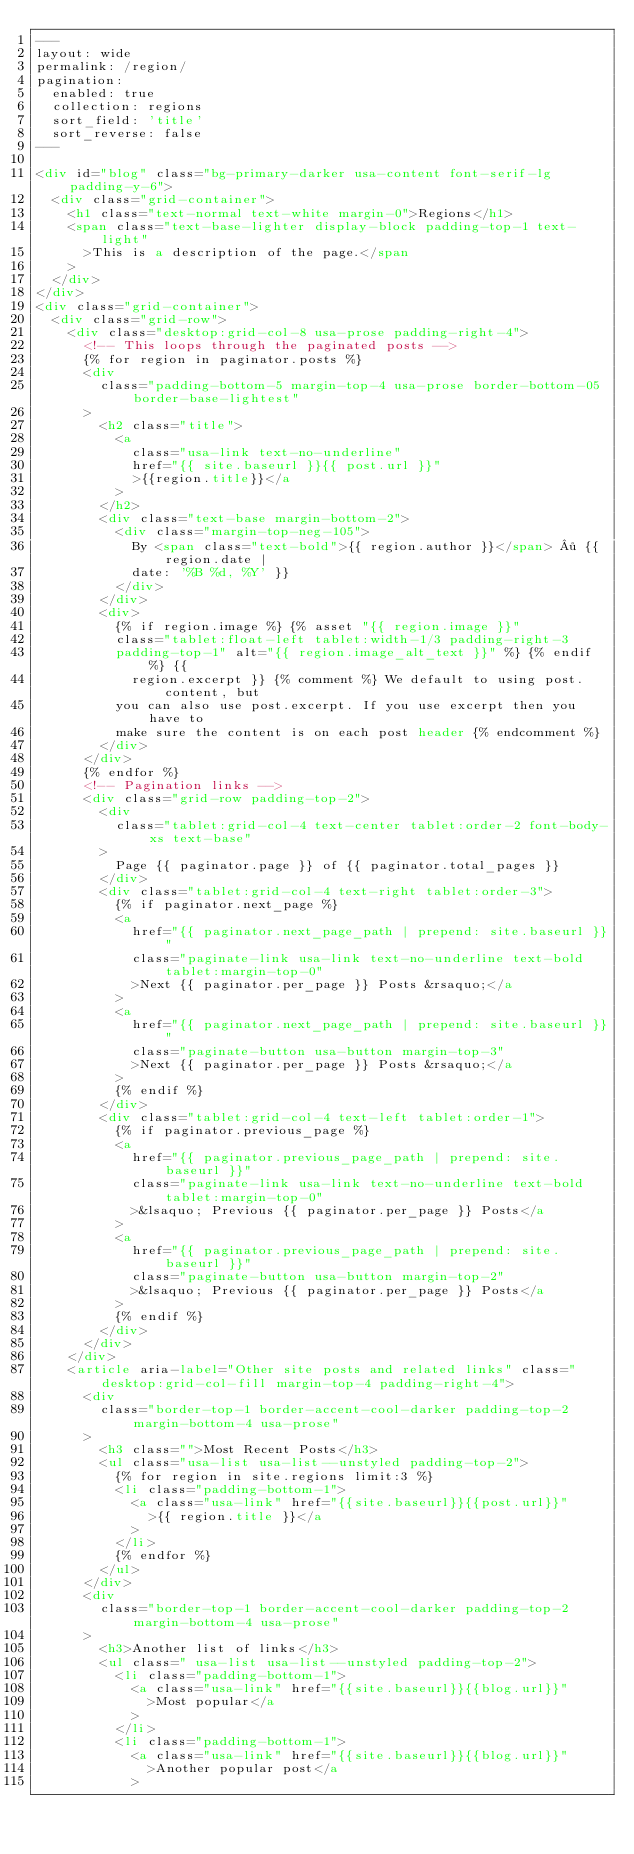Convert code to text. <code><loc_0><loc_0><loc_500><loc_500><_HTML_>---
layout: wide
permalink: /region/
pagination:
  enabled: true
  collection: regions
  sort_field: 'title'
  sort_reverse: false
---

<div id="blog" class="bg-primary-darker usa-content font-serif-lg padding-y-6">
  <div class="grid-container">
    <h1 class="text-normal text-white margin-0">Regions</h1>
    <span class="text-base-lighter display-block padding-top-1 text-light"
      >This is a description of the page.</span
    >
  </div>
</div>
<div class="grid-container">
  <div class="grid-row">
    <div class="desktop:grid-col-8 usa-prose padding-right-4">
      <!-- This loops through the paginated posts -->
      {% for region in paginator.posts %}
      <div
        class="padding-bottom-5 margin-top-4 usa-prose border-bottom-05 border-base-lightest"
      >
        <h2 class="title">
          <a
            class="usa-link text-no-underline"
            href="{{ site.baseurl }}{{ post.url }}"
            >{{region.title}}</a
          >
        </h2>
        <div class="text-base margin-bottom-2">
          <div class="margin-top-neg-105">
            By <span class="text-bold">{{ region.author }}</span> · {{ region.date |
            date: '%B %d, %Y' }}
          </div>
        </div>
        <div>
          {% if region.image %} {% asset "{{ region.image }}"
          class="tablet:float-left tablet:width-1/3 padding-right-3
          padding-top-1" alt="{{ region.image_alt_text }}" %} {% endif %} {{
            region.excerpt }} {% comment %} We default to using post.content, but
          you can also use post.excerpt. If you use excerpt then you have to
          make sure the content is on each post header {% endcomment %}
        </div>
      </div>
      {% endfor %}
      <!-- Pagination links -->
      <div class="grid-row padding-top-2">
        <div
          class="tablet:grid-col-4 text-center tablet:order-2 font-body-xs text-base"
        >
          Page {{ paginator.page }} of {{ paginator.total_pages }}
        </div>
        <div class="tablet:grid-col-4 text-right tablet:order-3">
          {% if paginator.next_page %}
          <a
            href="{{ paginator.next_page_path | prepend: site.baseurl }}"
            class="paginate-link usa-link text-no-underline text-bold tablet:margin-top-0"
            >Next {{ paginator.per_page }} Posts &rsaquo;</a
          >
          <a
            href="{{ paginator.next_page_path | prepend: site.baseurl }}"
            class="paginate-button usa-button margin-top-3"
            >Next {{ paginator.per_page }} Posts &rsaquo;</a
          >
          {% endif %}
        </div>
        <div class="tablet:grid-col-4 text-left tablet:order-1">
          {% if paginator.previous_page %}
          <a
            href="{{ paginator.previous_page_path | prepend: site.baseurl }}"
            class="paginate-link usa-link text-no-underline text-bold tablet:margin-top-0"
            >&lsaquo; Previous {{ paginator.per_page }} Posts</a
          >
          <a
            href="{{ paginator.previous_page_path | prepend: site.baseurl }}"
            class="paginate-button usa-button margin-top-2"
            >&lsaquo; Previous {{ paginator.per_page }} Posts</a
          >
          {% endif %}
        </div>
      </div>
    </div>
    <article aria-label="Other site posts and related links" class="desktop:grid-col-fill margin-top-4 padding-right-4">
      <div
        class="border-top-1 border-accent-cool-darker padding-top-2 margin-bottom-4 usa-prose"
      >
        <h3 class="">Most Recent Posts</h3>
        <ul class="usa-list usa-list--unstyled padding-top-2">
          {% for region in site.regions limit:3 %}
          <li class="padding-bottom-1">
            <a class="usa-link" href="{{site.baseurl}}{{post.url}}"
              >{{ region.title }}</a
            >
          </li>
          {% endfor %}
        </ul>
      </div>
      <div
        class="border-top-1 border-accent-cool-darker padding-top-2 margin-bottom-4 usa-prose"
      >
        <h3>Another list of links</h3>
        <ul class=" usa-list usa-list--unstyled padding-top-2">
          <li class="padding-bottom-1">
            <a class="usa-link" href="{{site.baseurl}}{{blog.url}}"
              >Most popular</a
            >
          </li>
          <li class="padding-bottom-1">
            <a class="usa-link" href="{{site.baseurl}}{{blog.url}}"
              >Another popular post</a
            ></code> 